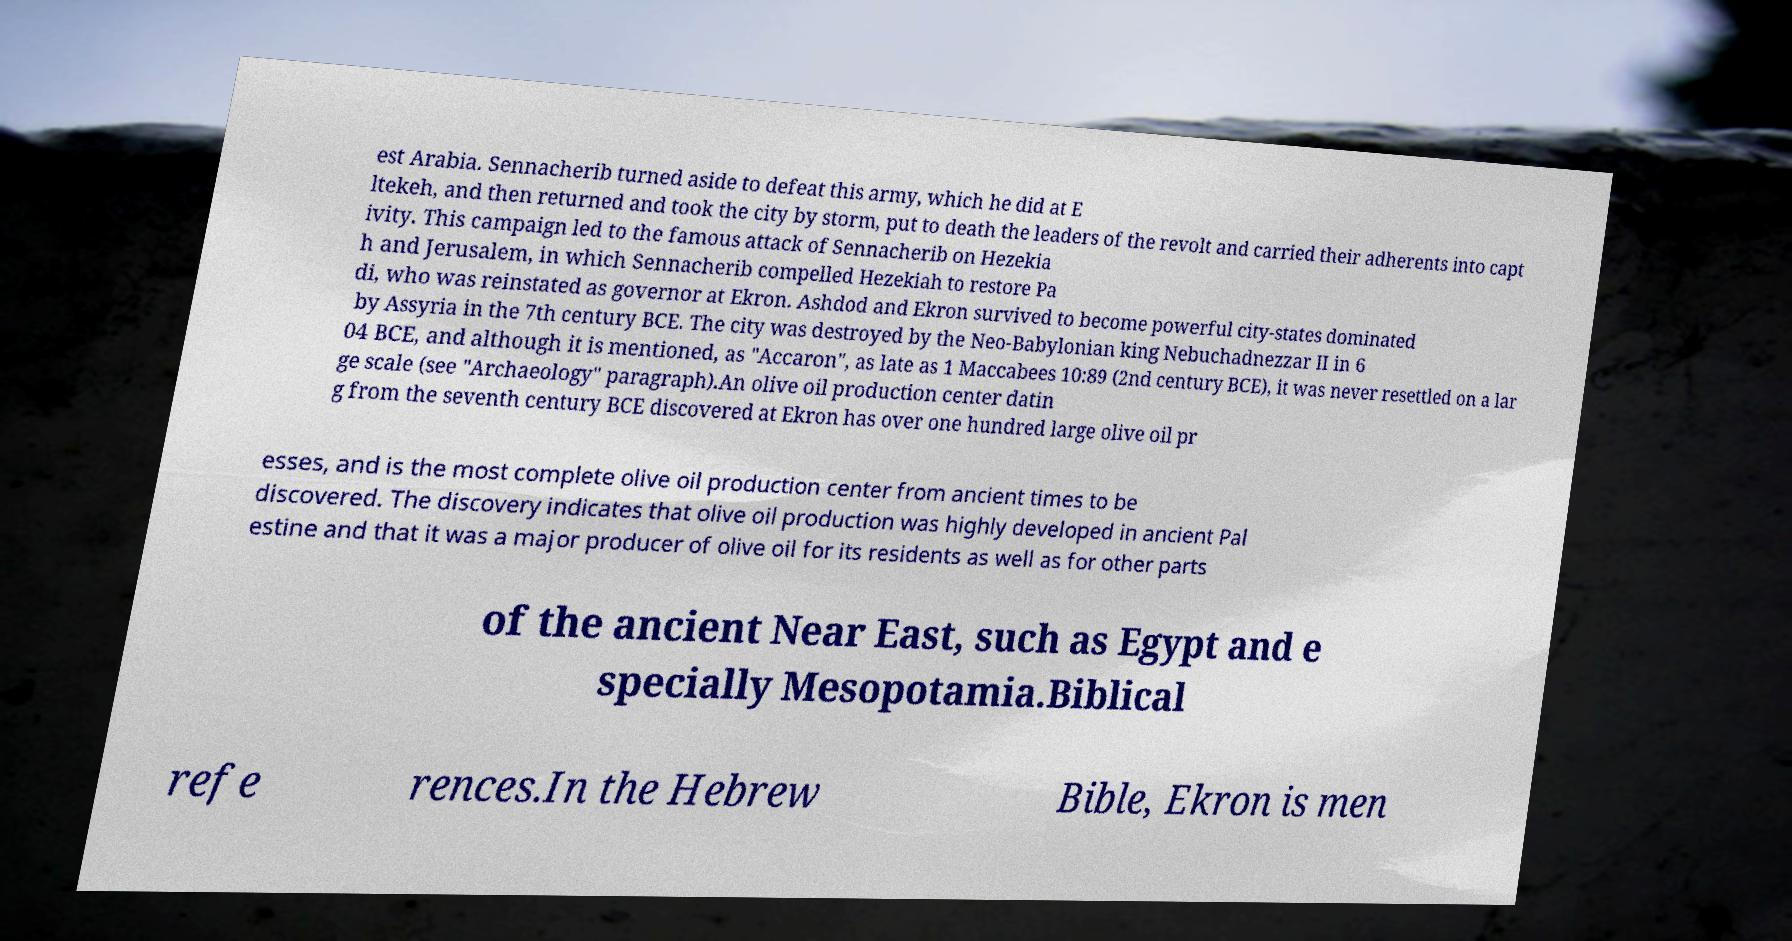Could you assist in decoding the text presented in this image and type it out clearly? est Arabia. Sennacherib turned aside to defeat this army, which he did at E ltekeh, and then returned and took the city by storm, put to death the leaders of the revolt and carried their adherents into capt ivity. This campaign led to the famous attack of Sennacherib on Hezekia h and Jerusalem, in which Sennacherib compelled Hezekiah to restore Pa di, who was reinstated as governor at Ekron. Ashdod and Ekron survived to become powerful city-states dominated by Assyria in the 7th century BCE. The city was destroyed by the Neo-Babylonian king Nebuchadnezzar II in 6 04 BCE, and although it is mentioned, as "Accaron", as late as 1 Maccabees 10:89 (2nd century BCE), it was never resettled on a lar ge scale (see "Archaeology" paragraph).An olive oil production center datin g from the seventh century BCE discovered at Ekron has over one hundred large olive oil pr esses, and is the most complete olive oil production center from ancient times to be discovered. The discovery indicates that olive oil production was highly developed in ancient Pal estine and that it was a major producer of olive oil for its residents as well as for other parts of the ancient Near East, such as Egypt and e specially Mesopotamia.Biblical refe rences.In the Hebrew Bible, Ekron is men 